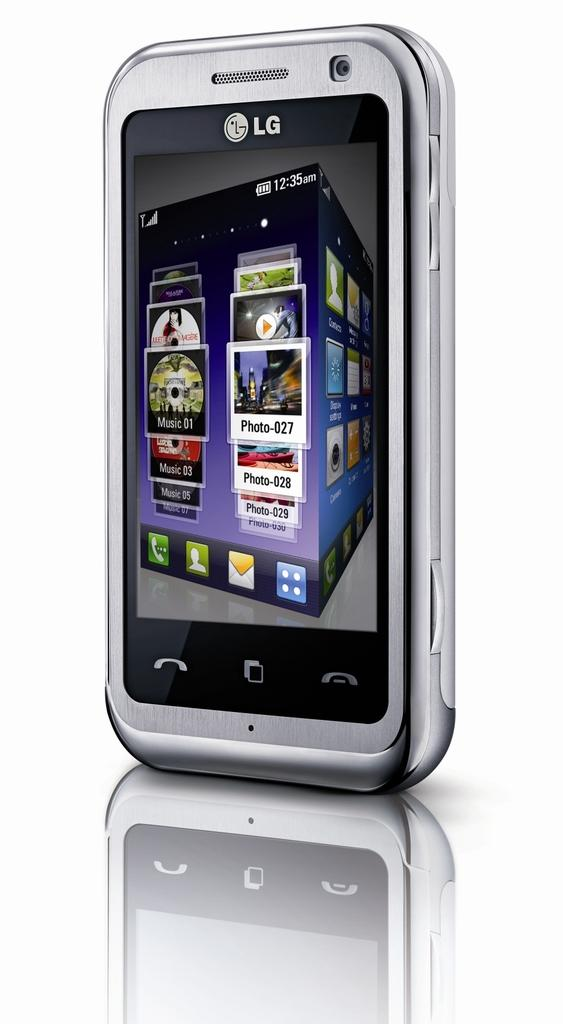<image>
Relay a brief, clear account of the picture shown. a phone that has LG at the top of it 